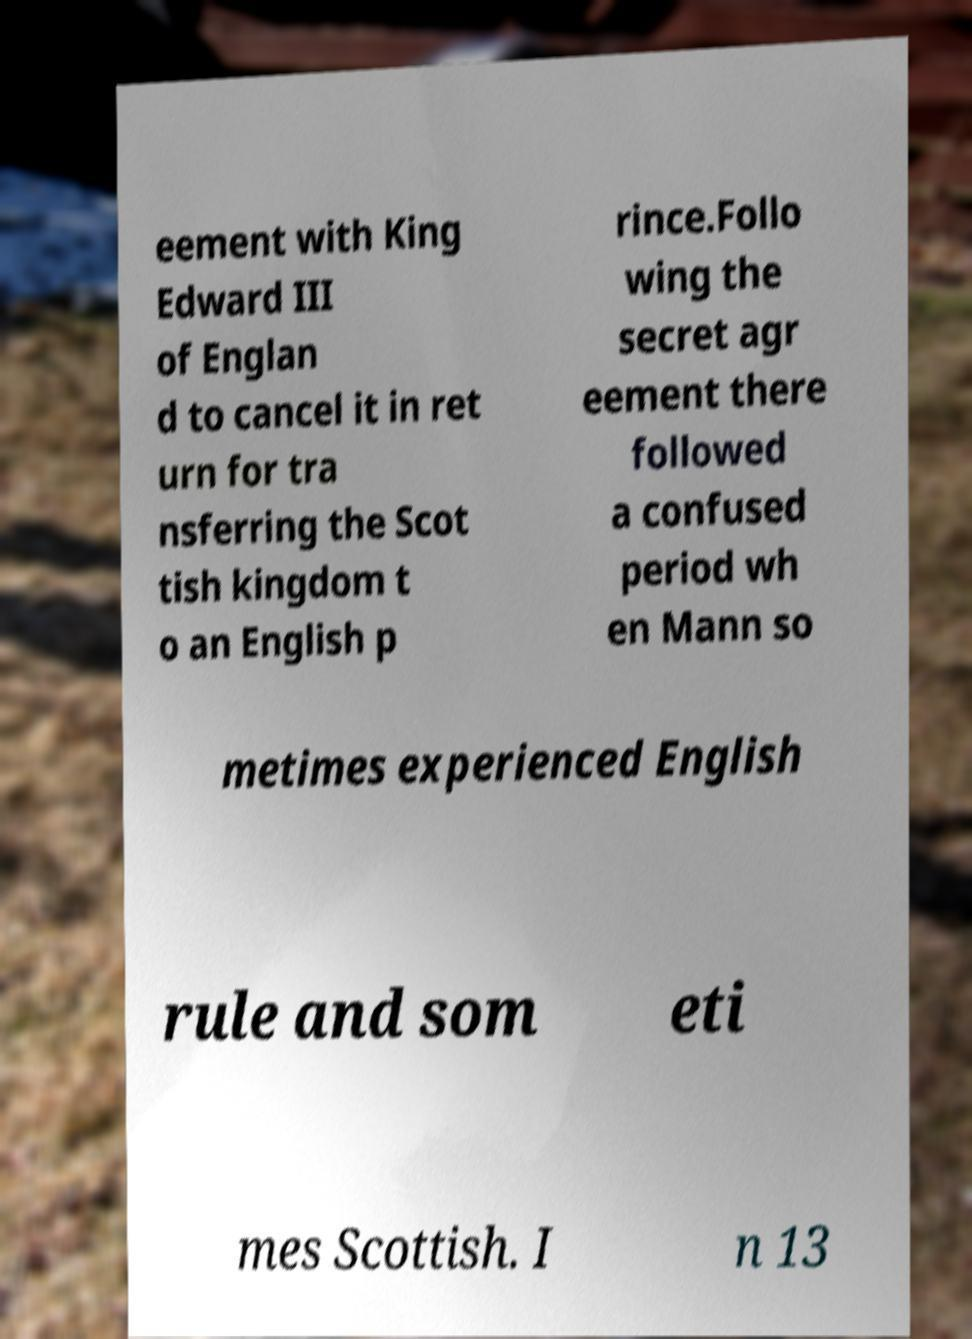Could you extract and type out the text from this image? eement with King Edward III of Englan d to cancel it in ret urn for tra nsferring the Scot tish kingdom t o an English p rince.Follo wing the secret agr eement there followed a confused period wh en Mann so metimes experienced English rule and som eti mes Scottish. I n 13 